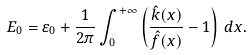Convert formula to latex. <formula><loc_0><loc_0><loc_500><loc_500>E _ { 0 } = \varepsilon _ { 0 } + \frac { 1 } { 2 \pi } \int _ { 0 } ^ { + \infty } \left ( \frac { \hat { k } ( x ) } { \hat { f } ( x ) } - 1 \right ) \, d x .</formula> 